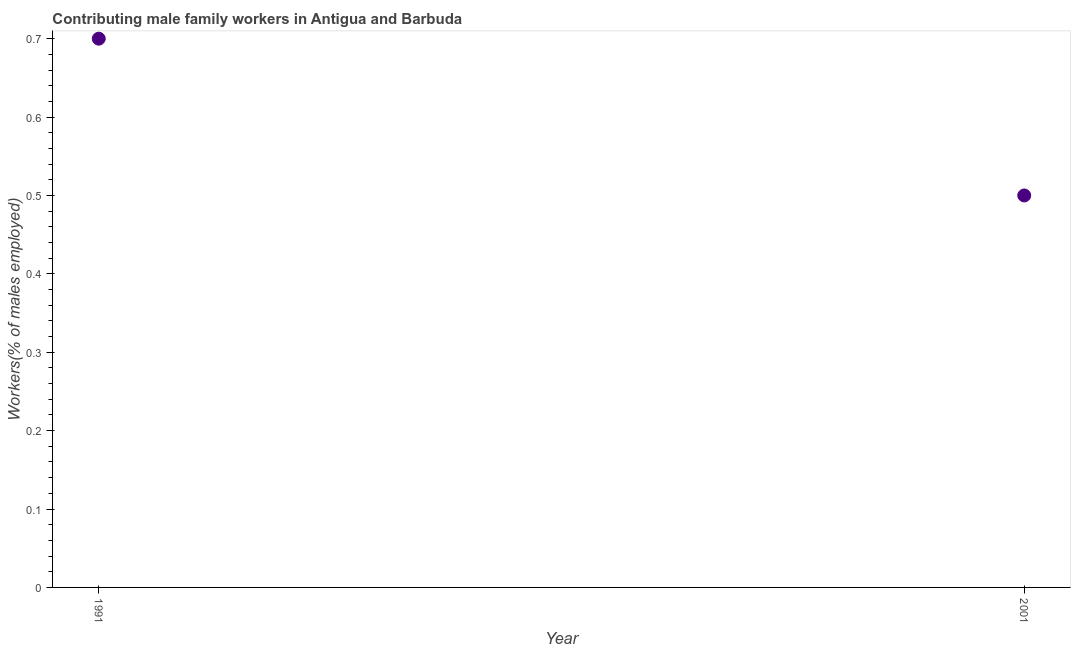What is the contributing male family workers in 1991?
Offer a very short reply. 0.7. Across all years, what is the maximum contributing male family workers?
Give a very brief answer. 0.7. Across all years, what is the minimum contributing male family workers?
Offer a terse response. 0.5. In which year was the contributing male family workers minimum?
Provide a short and direct response. 2001. What is the sum of the contributing male family workers?
Provide a succinct answer. 1.2. What is the difference between the contributing male family workers in 1991 and 2001?
Offer a very short reply. 0.2. What is the average contributing male family workers per year?
Your answer should be compact. 0.6. What is the median contributing male family workers?
Offer a very short reply. 0.6. What is the ratio of the contributing male family workers in 1991 to that in 2001?
Provide a short and direct response. 1.4. Is the contributing male family workers in 1991 less than that in 2001?
Ensure brevity in your answer.  No. In how many years, is the contributing male family workers greater than the average contributing male family workers taken over all years?
Your answer should be very brief. 1. Does the contributing male family workers monotonically increase over the years?
Keep it short and to the point. No. How many years are there in the graph?
Give a very brief answer. 2. Does the graph contain any zero values?
Give a very brief answer. No. Does the graph contain grids?
Give a very brief answer. No. What is the title of the graph?
Give a very brief answer. Contributing male family workers in Antigua and Barbuda. What is the label or title of the Y-axis?
Your answer should be compact. Workers(% of males employed). What is the Workers(% of males employed) in 1991?
Ensure brevity in your answer.  0.7. What is the difference between the Workers(% of males employed) in 1991 and 2001?
Provide a succinct answer. 0.2. What is the ratio of the Workers(% of males employed) in 1991 to that in 2001?
Provide a succinct answer. 1.4. 